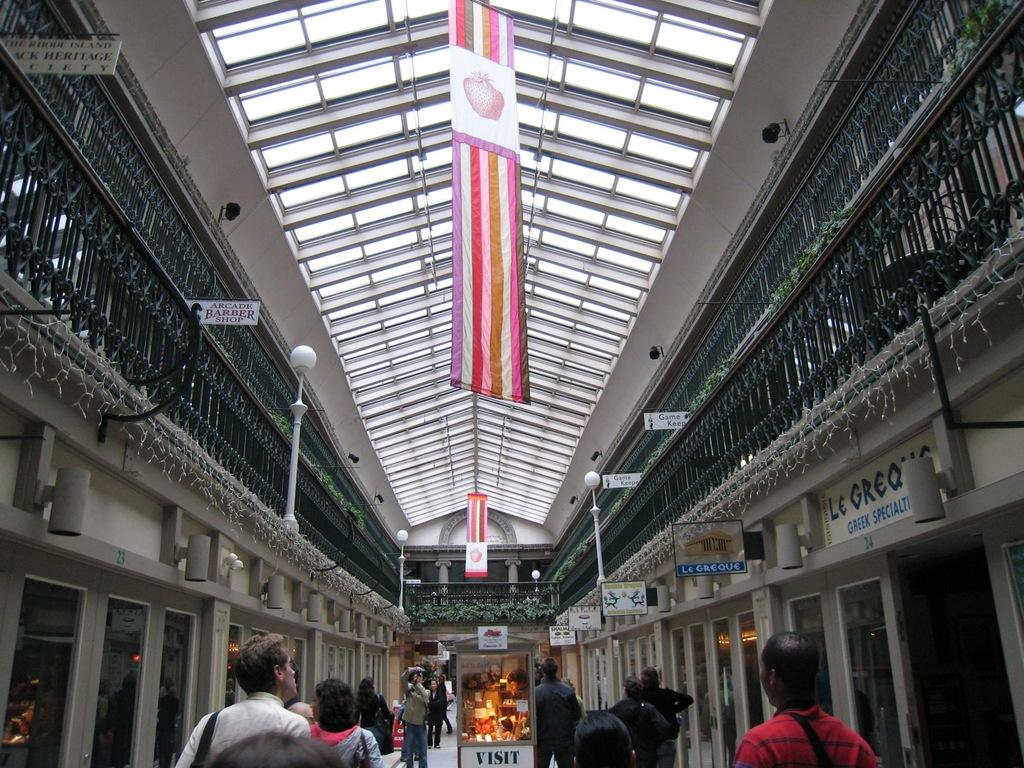What is happening at the bottom of the image? There are people walking at the bottom of the image. Where is the image most likely taken? The image appears to be an inside part of a building. What can be seen at the top of the image? There is a roof visible at the top of the image. What type of system is being used by the people walking in the image? There is no specific system mentioned or visible in the image; people are simply walking. Can you see any stems in the image? There are no stems present in the image. 